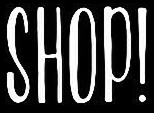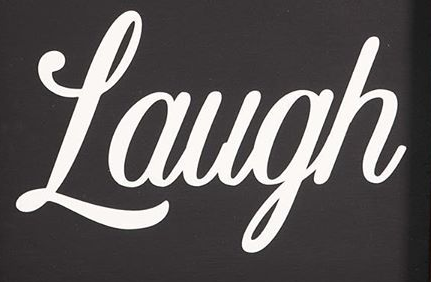Read the text from these images in sequence, separated by a semicolon. SHOP!; Laugh 